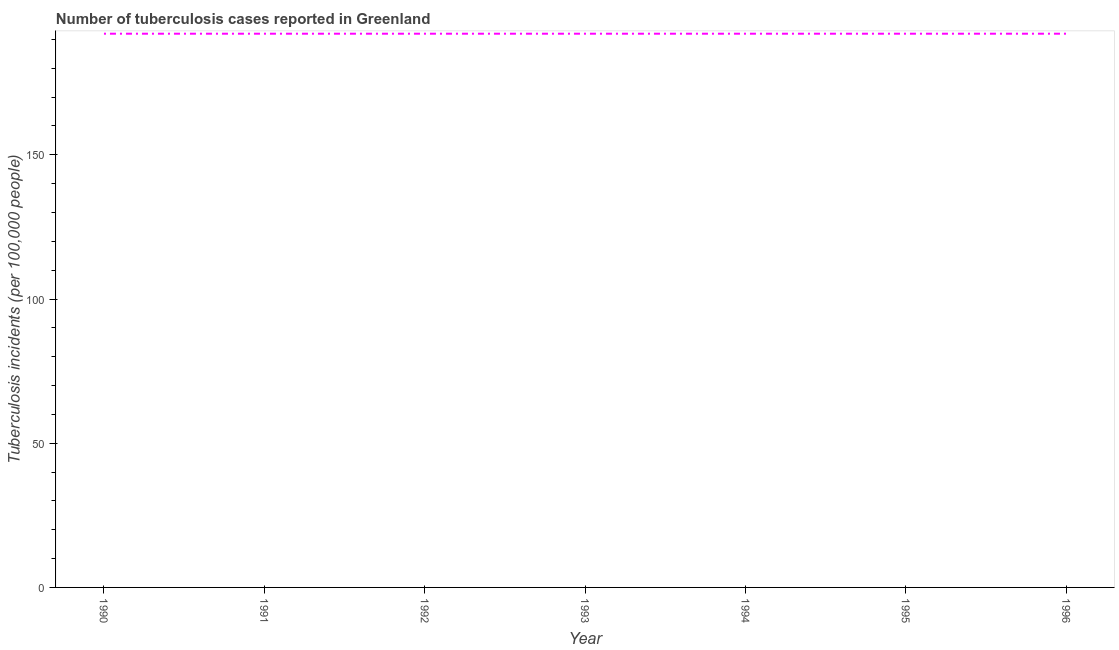What is the number of tuberculosis incidents in 1995?
Your answer should be very brief. 192. Across all years, what is the maximum number of tuberculosis incidents?
Keep it short and to the point. 192. Across all years, what is the minimum number of tuberculosis incidents?
Make the answer very short. 192. What is the sum of the number of tuberculosis incidents?
Provide a short and direct response. 1344. What is the difference between the number of tuberculosis incidents in 1994 and 1995?
Offer a terse response. 0. What is the average number of tuberculosis incidents per year?
Offer a very short reply. 192. What is the median number of tuberculosis incidents?
Give a very brief answer. 192. What is the difference between the highest and the second highest number of tuberculosis incidents?
Make the answer very short. 0. Does the number of tuberculosis incidents monotonically increase over the years?
Your answer should be compact. No. What is the difference between two consecutive major ticks on the Y-axis?
Give a very brief answer. 50. Are the values on the major ticks of Y-axis written in scientific E-notation?
Ensure brevity in your answer.  No. Does the graph contain any zero values?
Keep it short and to the point. No. What is the title of the graph?
Make the answer very short. Number of tuberculosis cases reported in Greenland. What is the label or title of the Y-axis?
Give a very brief answer. Tuberculosis incidents (per 100,0 people). What is the Tuberculosis incidents (per 100,000 people) of 1990?
Your response must be concise. 192. What is the Tuberculosis incidents (per 100,000 people) in 1991?
Offer a terse response. 192. What is the Tuberculosis incidents (per 100,000 people) of 1992?
Your answer should be compact. 192. What is the Tuberculosis incidents (per 100,000 people) in 1993?
Your answer should be compact. 192. What is the Tuberculosis incidents (per 100,000 people) in 1994?
Your answer should be very brief. 192. What is the Tuberculosis incidents (per 100,000 people) of 1995?
Give a very brief answer. 192. What is the Tuberculosis incidents (per 100,000 people) of 1996?
Your answer should be very brief. 192. What is the difference between the Tuberculosis incidents (per 100,000 people) in 1990 and 1991?
Give a very brief answer. 0. What is the difference between the Tuberculosis incidents (per 100,000 people) in 1990 and 1994?
Your answer should be very brief. 0. What is the difference between the Tuberculosis incidents (per 100,000 people) in 1990 and 1995?
Provide a short and direct response. 0. What is the difference between the Tuberculosis incidents (per 100,000 people) in 1991 and 1993?
Your answer should be compact. 0. What is the difference between the Tuberculosis incidents (per 100,000 people) in 1991 and 1996?
Offer a terse response. 0. What is the difference between the Tuberculosis incidents (per 100,000 people) in 1992 and 1994?
Provide a short and direct response. 0. What is the difference between the Tuberculosis incidents (per 100,000 people) in 1992 and 1995?
Provide a short and direct response. 0. What is the difference between the Tuberculosis incidents (per 100,000 people) in 1992 and 1996?
Your answer should be compact. 0. What is the difference between the Tuberculosis incidents (per 100,000 people) in 1993 and 1994?
Provide a succinct answer. 0. What is the difference between the Tuberculosis incidents (per 100,000 people) in 1993 and 1995?
Give a very brief answer. 0. What is the difference between the Tuberculosis incidents (per 100,000 people) in 1994 and 1995?
Give a very brief answer. 0. What is the difference between the Tuberculosis incidents (per 100,000 people) in 1995 and 1996?
Your response must be concise. 0. What is the ratio of the Tuberculosis incidents (per 100,000 people) in 1990 to that in 1991?
Offer a very short reply. 1. What is the ratio of the Tuberculosis incidents (per 100,000 people) in 1990 to that in 1992?
Provide a short and direct response. 1. What is the ratio of the Tuberculosis incidents (per 100,000 people) in 1990 to that in 1994?
Ensure brevity in your answer.  1. What is the ratio of the Tuberculosis incidents (per 100,000 people) in 1990 to that in 1995?
Provide a succinct answer. 1. What is the ratio of the Tuberculosis incidents (per 100,000 people) in 1991 to that in 1992?
Your answer should be very brief. 1. What is the ratio of the Tuberculosis incidents (per 100,000 people) in 1991 to that in 1993?
Make the answer very short. 1. What is the ratio of the Tuberculosis incidents (per 100,000 people) in 1991 to that in 1996?
Your answer should be very brief. 1. What is the ratio of the Tuberculosis incidents (per 100,000 people) in 1992 to that in 1993?
Your response must be concise. 1. What is the ratio of the Tuberculosis incidents (per 100,000 people) in 1992 to that in 1994?
Offer a very short reply. 1. What is the ratio of the Tuberculosis incidents (per 100,000 people) in 1993 to that in 1994?
Make the answer very short. 1. What is the ratio of the Tuberculosis incidents (per 100,000 people) in 1993 to that in 1996?
Provide a short and direct response. 1. What is the ratio of the Tuberculosis incidents (per 100,000 people) in 1994 to that in 1996?
Your response must be concise. 1. 